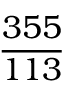<formula> <loc_0><loc_0><loc_500><loc_500>\frac { 3 5 5 } { 1 1 3 }</formula> 